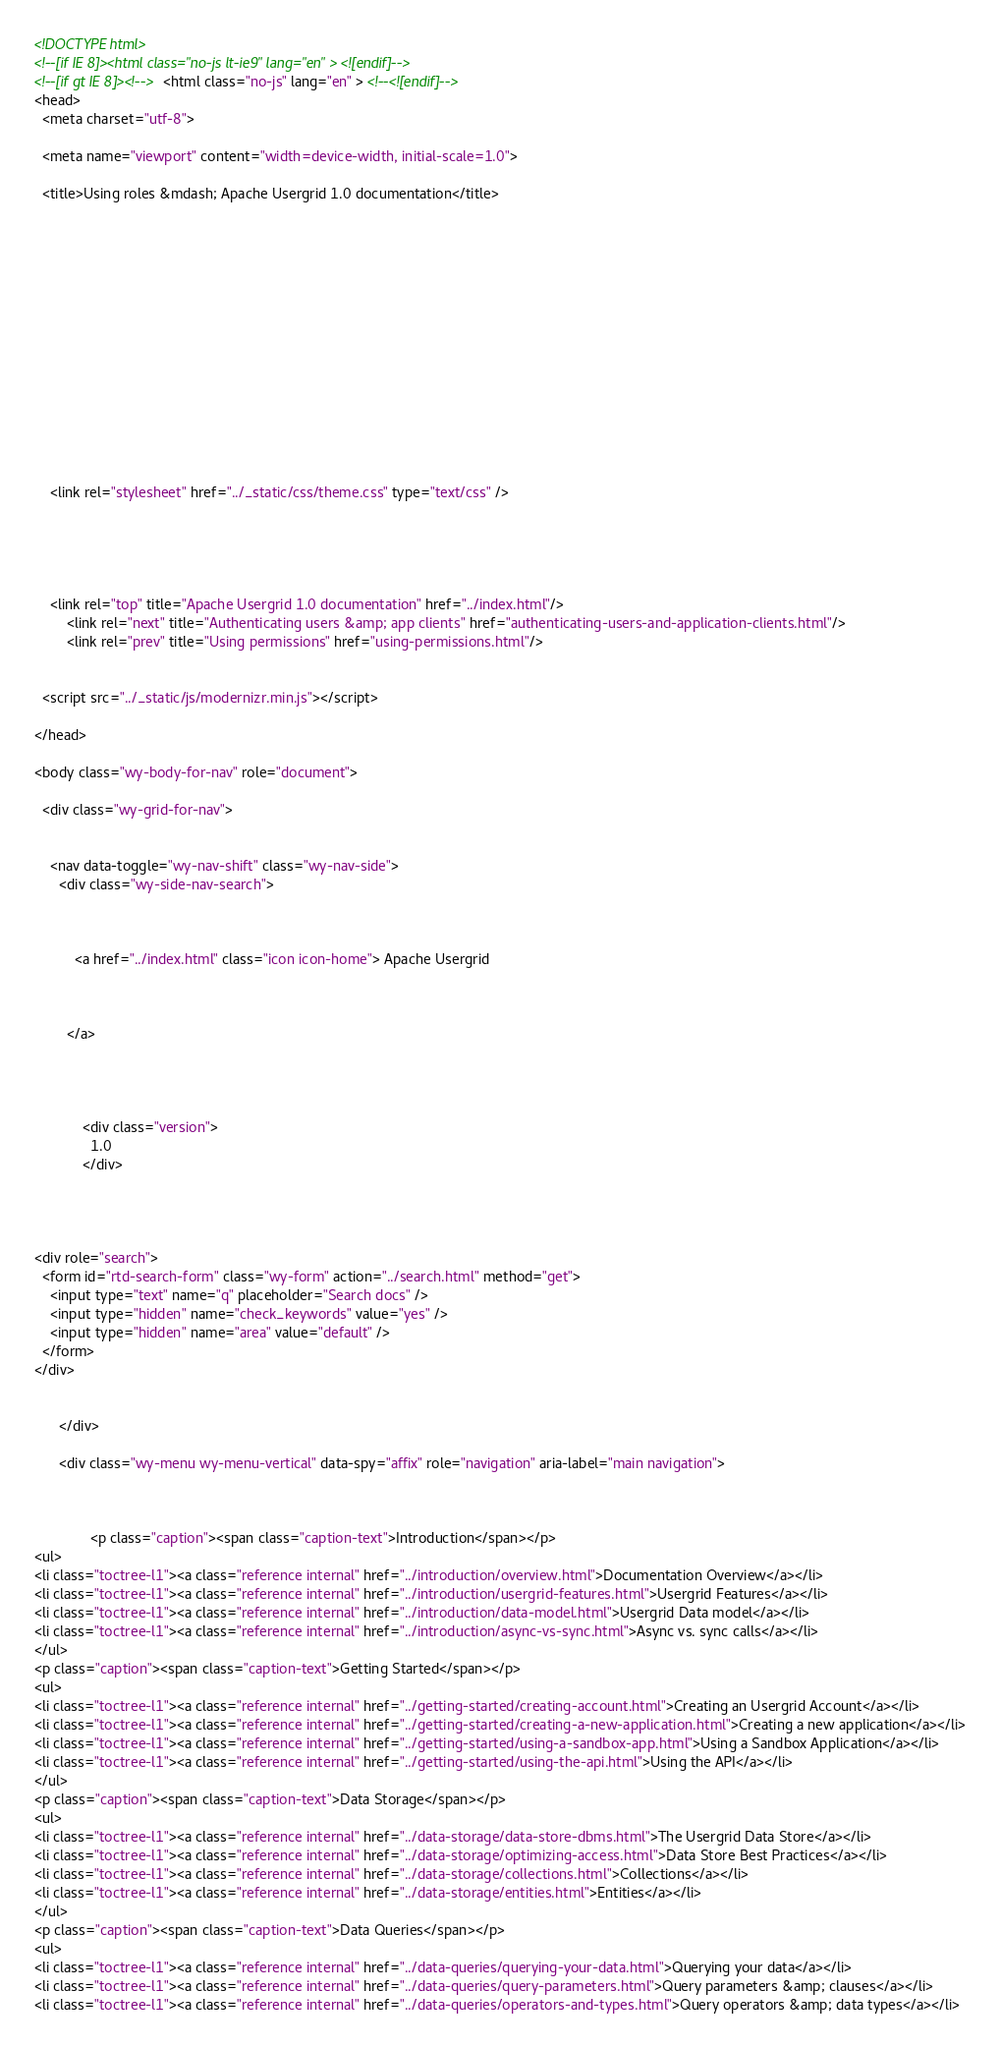Convert code to text. <code><loc_0><loc_0><loc_500><loc_500><_HTML_>

<!DOCTYPE html>
<!--[if IE 8]><html class="no-js lt-ie9" lang="en" > <![endif]-->
<!--[if gt IE 8]><!--> <html class="no-js" lang="en" > <!--<![endif]-->
<head>
  <meta charset="utf-8">
  
  <meta name="viewport" content="width=device-width, initial-scale=1.0">
  
  <title>Using roles &mdash; Apache Usergrid 1.0 documentation</title>
  

  
  

  

  
  
    

  

  
  
    <link rel="stylesheet" href="../_static/css/theme.css" type="text/css" />
  

  

  
    <link rel="top" title="Apache Usergrid 1.0 documentation" href="../index.html"/>
        <link rel="next" title="Authenticating users &amp; app clients" href="authenticating-users-and-application-clients.html"/>
        <link rel="prev" title="Using permissions" href="using-permissions.html"/> 

  
  <script src="../_static/js/modernizr.min.js"></script>

</head>

<body class="wy-body-for-nav" role="document">

  <div class="wy-grid-for-nav">

    
    <nav data-toggle="wy-nav-shift" class="wy-nav-side">
      <div class="wy-side-nav-search">
        

        
          <a href="../index.html" class="icon icon-home"> Apache Usergrid
        

        
        </a>

        
          
          
            <div class="version">
              1.0
            </div>
          
        

        
<div role="search">
  <form id="rtd-search-form" class="wy-form" action="../search.html" method="get">
    <input type="text" name="q" placeholder="Search docs" />
    <input type="hidden" name="check_keywords" value="yes" />
    <input type="hidden" name="area" value="default" />
  </form>
</div>

        
      </div>

      <div class="wy-menu wy-menu-vertical" data-spy="affix" role="navigation" aria-label="main navigation">
        
          
          
              <p class="caption"><span class="caption-text">Introduction</span></p>
<ul>
<li class="toctree-l1"><a class="reference internal" href="../introduction/overview.html">Documentation Overview</a></li>
<li class="toctree-l1"><a class="reference internal" href="../introduction/usergrid-features.html">Usergrid Features</a></li>
<li class="toctree-l1"><a class="reference internal" href="../introduction/data-model.html">Usergrid Data model</a></li>
<li class="toctree-l1"><a class="reference internal" href="../introduction/async-vs-sync.html">Async vs. sync calls</a></li>
</ul>
<p class="caption"><span class="caption-text">Getting Started</span></p>
<ul>
<li class="toctree-l1"><a class="reference internal" href="../getting-started/creating-account.html">Creating an Usergrid Account</a></li>
<li class="toctree-l1"><a class="reference internal" href="../getting-started/creating-a-new-application.html">Creating a new application</a></li>
<li class="toctree-l1"><a class="reference internal" href="../getting-started/using-a-sandbox-app.html">Using a Sandbox Application</a></li>
<li class="toctree-l1"><a class="reference internal" href="../getting-started/using-the-api.html">Using the API</a></li>
</ul>
<p class="caption"><span class="caption-text">Data Storage</span></p>
<ul>
<li class="toctree-l1"><a class="reference internal" href="../data-storage/data-store-dbms.html">The Usergrid Data Store</a></li>
<li class="toctree-l1"><a class="reference internal" href="../data-storage/optimizing-access.html">Data Store Best Practices</a></li>
<li class="toctree-l1"><a class="reference internal" href="../data-storage/collections.html">Collections</a></li>
<li class="toctree-l1"><a class="reference internal" href="../data-storage/entities.html">Entities</a></li>
</ul>
<p class="caption"><span class="caption-text">Data Queries</span></p>
<ul>
<li class="toctree-l1"><a class="reference internal" href="../data-queries/querying-your-data.html">Querying your data</a></li>
<li class="toctree-l1"><a class="reference internal" href="../data-queries/query-parameters.html">Query parameters &amp; clauses</a></li>
<li class="toctree-l1"><a class="reference internal" href="../data-queries/operators-and-types.html">Query operators &amp; data types</a></li></code> 